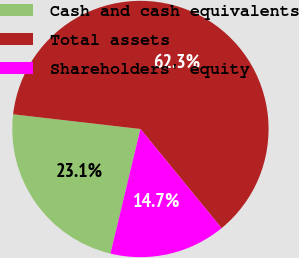<chart> <loc_0><loc_0><loc_500><loc_500><pie_chart><fcel>Cash and cash equivalents<fcel>Total assets<fcel>Shareholders' equity<nl><fcel>23.07%<fcel>62.26%<fcel>14.67%<nl></chart> 